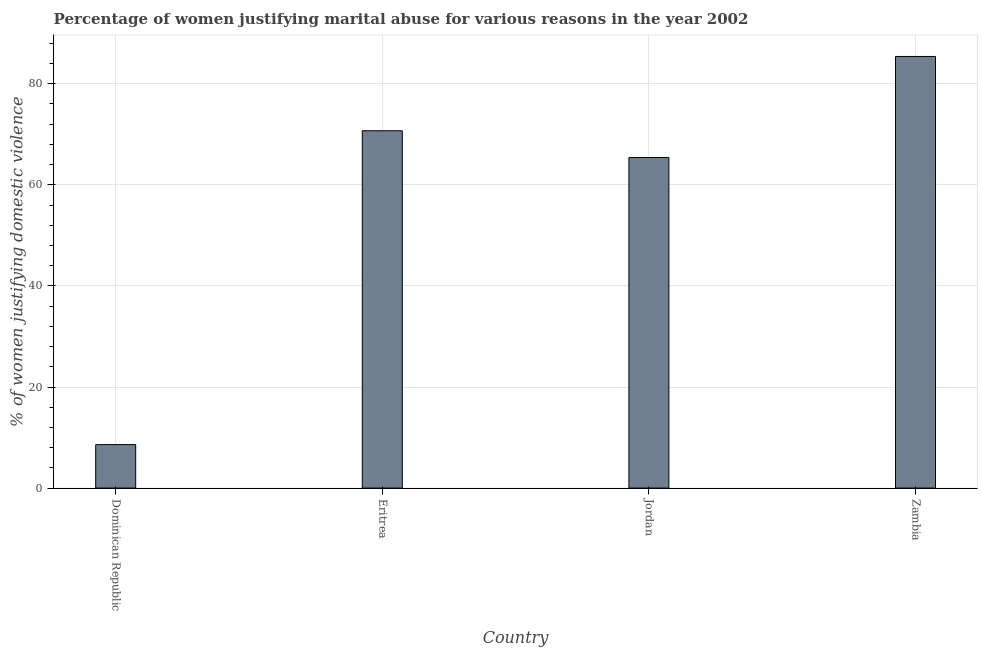Does the graph contain any zero values?
Give a very brief answer. No. Does the graph contain grids?
Provide a succinct answer. Yes. What is the title of the graph?
Give a very brief answer. Percentage of women justifying marital abuse for various reasons in the year 2002. What is the label or title of the Y-axis?
Offer a very short reply. % of women justifying domestic violence. What is the percentage of women justifying marital abuse in Zambia?
Your response must be concise. 85.4. Across all countries, what is the maximum percentage of women justifying marital abuse?
Make the answer very short. 85.4. In which country was the percentage of women justifying marital abuse maximum?
Your answer should be very brief. Zambia. In which country was the percentage of women justifying marital abuse minimum?
Ensure brevity in your answer.  Dominican Republic. What is the sum of the percentage of women justifying marital abuse?
Ensure brevity in your answer.  230.1. What is the difference between the percentage of women justifying marital abuse in Eritrea and Zambia?
Offer a very short reply. -14.7. What is the average percentage of women justifying marital abuse per country?
Provide a succinct answer. 57.52. What is the median percentage of women justifying marital abuse?
Provide a succinct answer. 68.05. What is the ratio of the percentage of women justifying marital abuse in Dominican Republic to that in Eritrea?
Ensure brevity in your answer.  0.12. Is the difference between the percentage of women justifying marital abuse in Dominican Republic and Eritrea greater than the difference between any two countries?
Your answer should be compact. No. What is the difference between the highest and the lowest percentage of women justifying marital abuse?
Make the answer very short. 76.8. How many bars are there?
Provide a short and direct response. 4. How many countries are there in the graph?
Offer a very short reply. 4. What is the difference between two consecutive major ticks on the Y-axis?
Provide a short and direct response. 20. Are the values on the major ticks of Y-axis written in scientific E-notation?
Your answer should be very brief. No. What is the % of women justifying domestic violence in Dominican Republic?
Offer a very short reply. 8.6. What is the % of women justifying domestic violence of Eritrea?
Your answer should be very brief. 70.7. What is the % of women justifying domestic violence of Jordan?
Your response must be concise. 65.4. What is the % of women justifying domestic violence in Zambia?
Keep it short and to the point. 85.4. What is the difference between the % of women justifying domestic violence in Dominican Republic and Eritrea?
Keep it short and to the point. -62.1. What is the difference between the % of women justifying domestic violence in Dominican Republic and Jordan?
Your answer should be compact. -56.8. What is the difference between the % of women justifying domestic violence in Dominican Republic and Zambia?
Your response must be concise. -76.8. What is the difference between the % of women justifying domestic violence in Eritrea and Zambia?
Keep it short and to the point. -14.7. What is the ratio of the % of women justifying domestic violence in Dominican Republic to that in Eritrea?
Make the answer very short. 0.12. What is the ratio of the % of women justifying domestic violence in Dominican Republic to that in Jordan?
Your answer should be very brief. 0.13. What is the ratio of the % of women justifying domestic violence in Dominican Republic to that in Zambia?
Your answer should be very brief. 0.1. What is the ratio of the % of women justifying domestic violence in Eritrea to that in Jordan?
Give a very brief answer. 1.08. What is the ratio of the % of women justifying domestic violence in Eritrea to that in Zambia?
Offer a terse response. 0.83. What is the ratio of the % of women justifying domestic violence in Jordan to that in Zambia?
Make the answer very short. 0.77. 